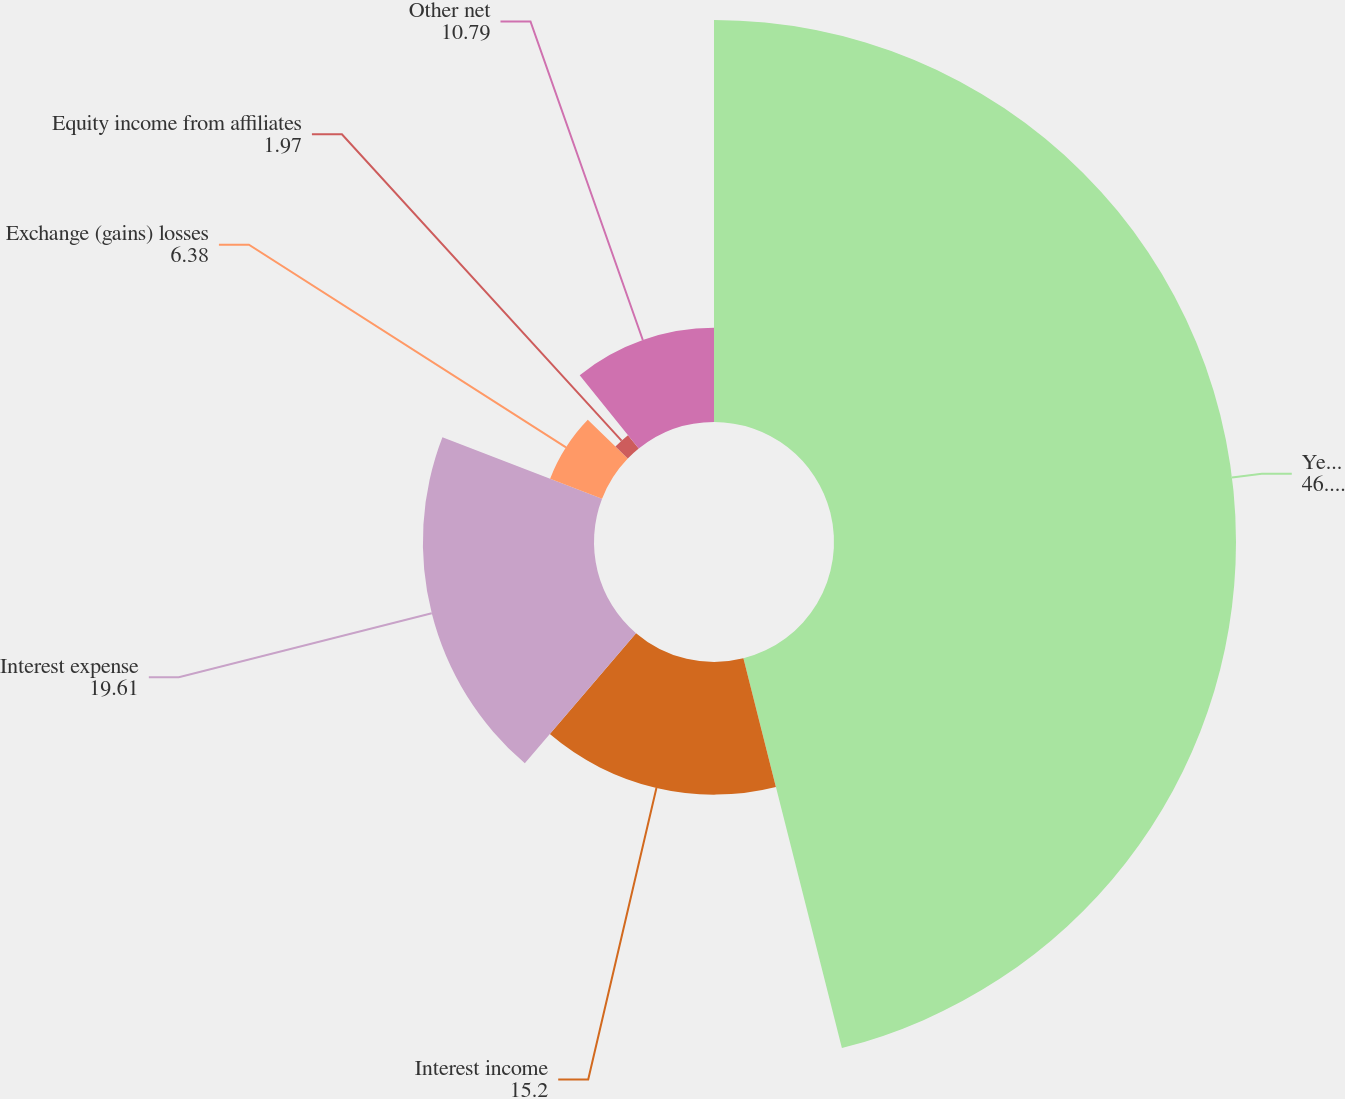<chart> <loc_0><loc_0><loc_500><loc_500><pie_chart><fcel>Years Ended December 31<fcel>Interest income<fcel>Interest expense<fcel>Exchange (gains) losses<fcel>Equity income from affiliates<fcel>Other net<nl><fcel>46.07%<fcel>15.2%<fcel>19.61%<fcel>6.38%<fcel>1.97%<fcel>10.79%<nl></chart> 